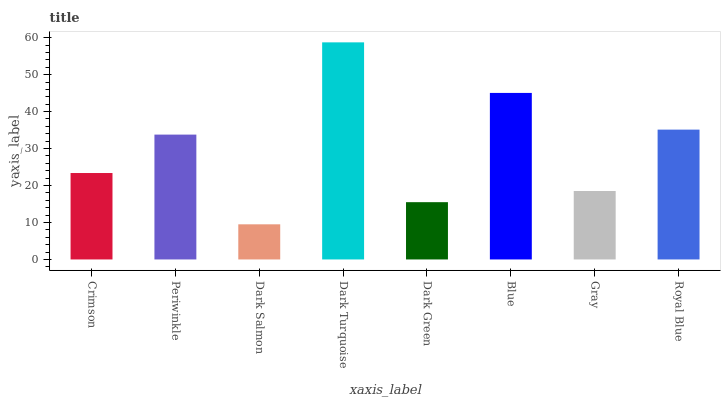Is Dark Salmon the minimum?
Answer yes or no. Yes. Is Dark Turquoise the maximum?
Answer yes or no. Yes. Is Periwinkle the minimum?
Answer yes or no. No. Is Periwinkle the maximum?
Answer yes or no. No. Is Periwinkle greater than Crimson?
Answer yes or no. Yes. Is Crimson less than Periwinkle?
Answer yes or no. Yes. Is Crimson greater than Periwinkle?
Answer yes or no. No. Is Periwinkle less than Crimson?
Answer yes or no. No. Is Periwinkle the high median?
Answer yes or no. Yes. Is Crimson the low median?
Answer yes or no. Yes. Is Dark Turquoise the high median?
Answer yes or no. No. Is Royal Blue the low median?
Answer yes or no. No. 